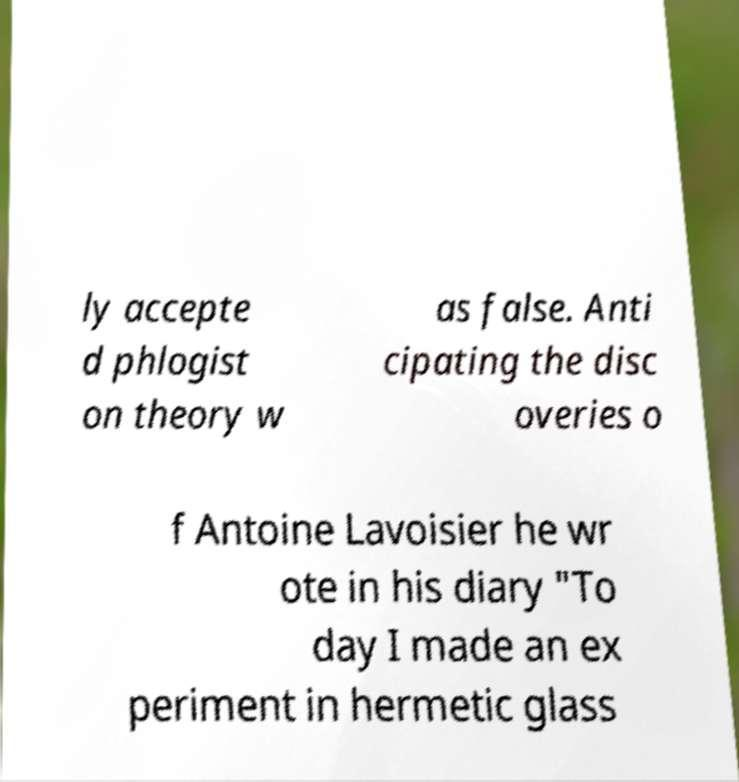I need the written content from this picture converted into text. Can you do that? ly accepte d phlogist on theory w as false. Anti cipating the disc overies o f Antoine Lavoisier he wr ote in his diary "To day I made an ex periment in hermetic glass 